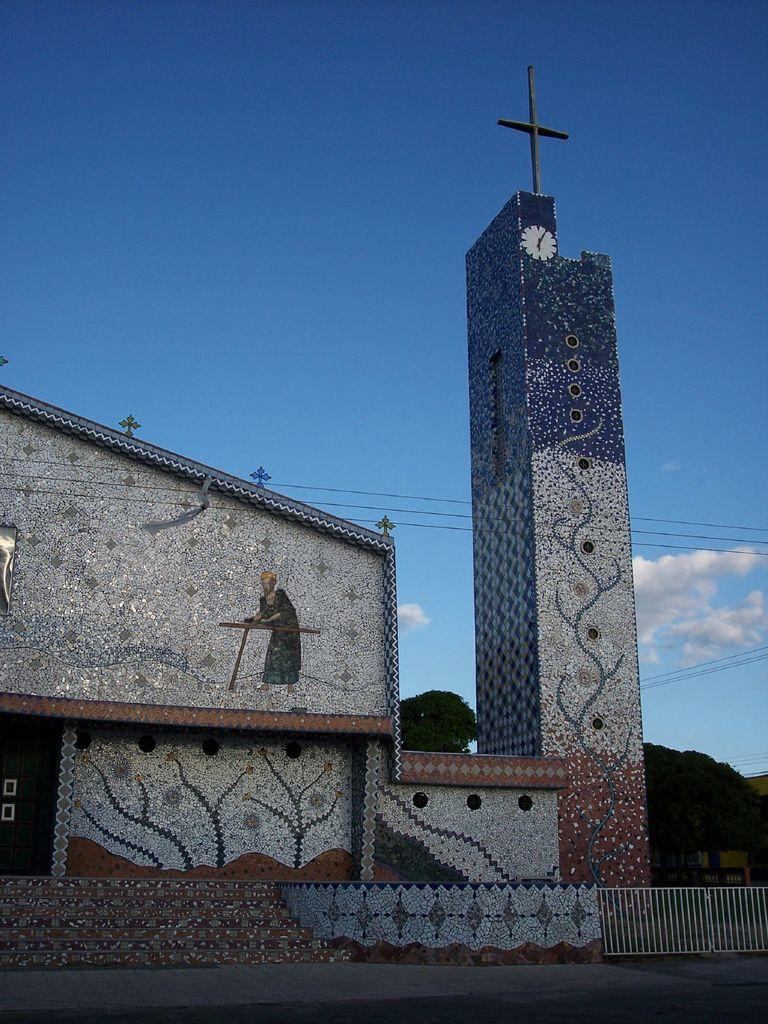What type of structure is present in the image? There is a building in the image. Can you describe any specific features of the building? There is a clock tower in the image. What can be seen in the background of the image? There are trees in the background of the image. What type of brass instrument is being played by the daughter in the image? There is no daughter or brass instrument present in the image. 